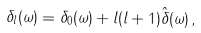<formula> <loc_0><loc_0><loc_500><loc_500>\delta _ { l } ( \omega ) = \delta _ { 0 } ( \omega ) + l ( l + 1 ) \hat { \delta } ( \omega ) \, ,</formula> 